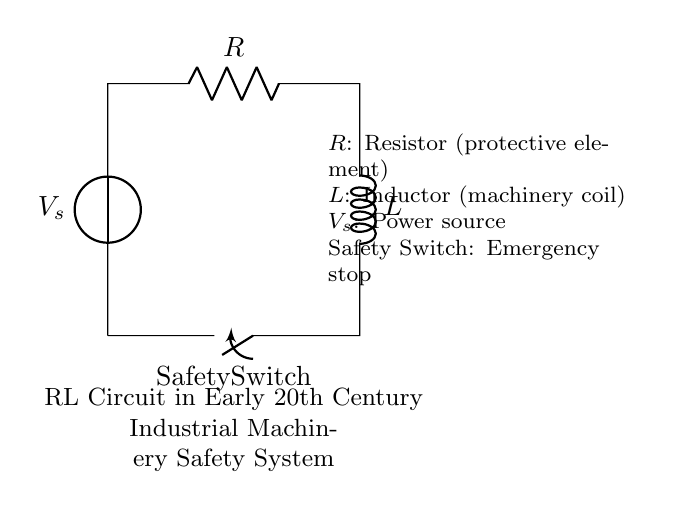What type of circuit is depicted in the diagram? The circuit is an RL circuit, which consists of a resistor and an inductor connected in series. The presence of both components indicates that it is specifically designed to manage current flow and provide safety in industrial machinery.
Answer: RL circuit What is the role of the resistor in this circuit? The resistor acts as a protective element, which means it helps to limit the current flowing through the circuit and thereby protects the inductor and other components from potential damage due to excessive current.
Answer: Protective element What does the safety switch signify in the diagram? The safety switch represents an emergency stop mechanism that can open the circuit to immediately cut off the power supply, ensuring safety during operation and maintenance of the machinery.
Answer: Emergency stop What is likely to happen when the safety switch is opened? When the safety switch is opened, the circuit will be interrupted, causing the current to stop flowing through the resistor and inductor, which immediately minimizes the risk of overload and protects the machinery from operation hazards.
Answer: Current stops How does the inductor function in this circuit? The inductor stores energy in the form of a magnetic field when current passes through it, and it opposes changes in current flow, providing stability to the circuit and helping to ensure smooth operation of machinery by smoothing out fluctuations in current.
Answer: Machinery coil 